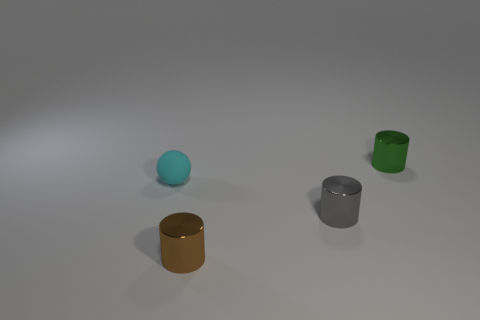What is the color of the small cylinder behind the small cyan rubber object? The small cylinder positioned behind the small cyan rubber object is colored green, with a matte finish that suggests a non-reflective surface texture. 